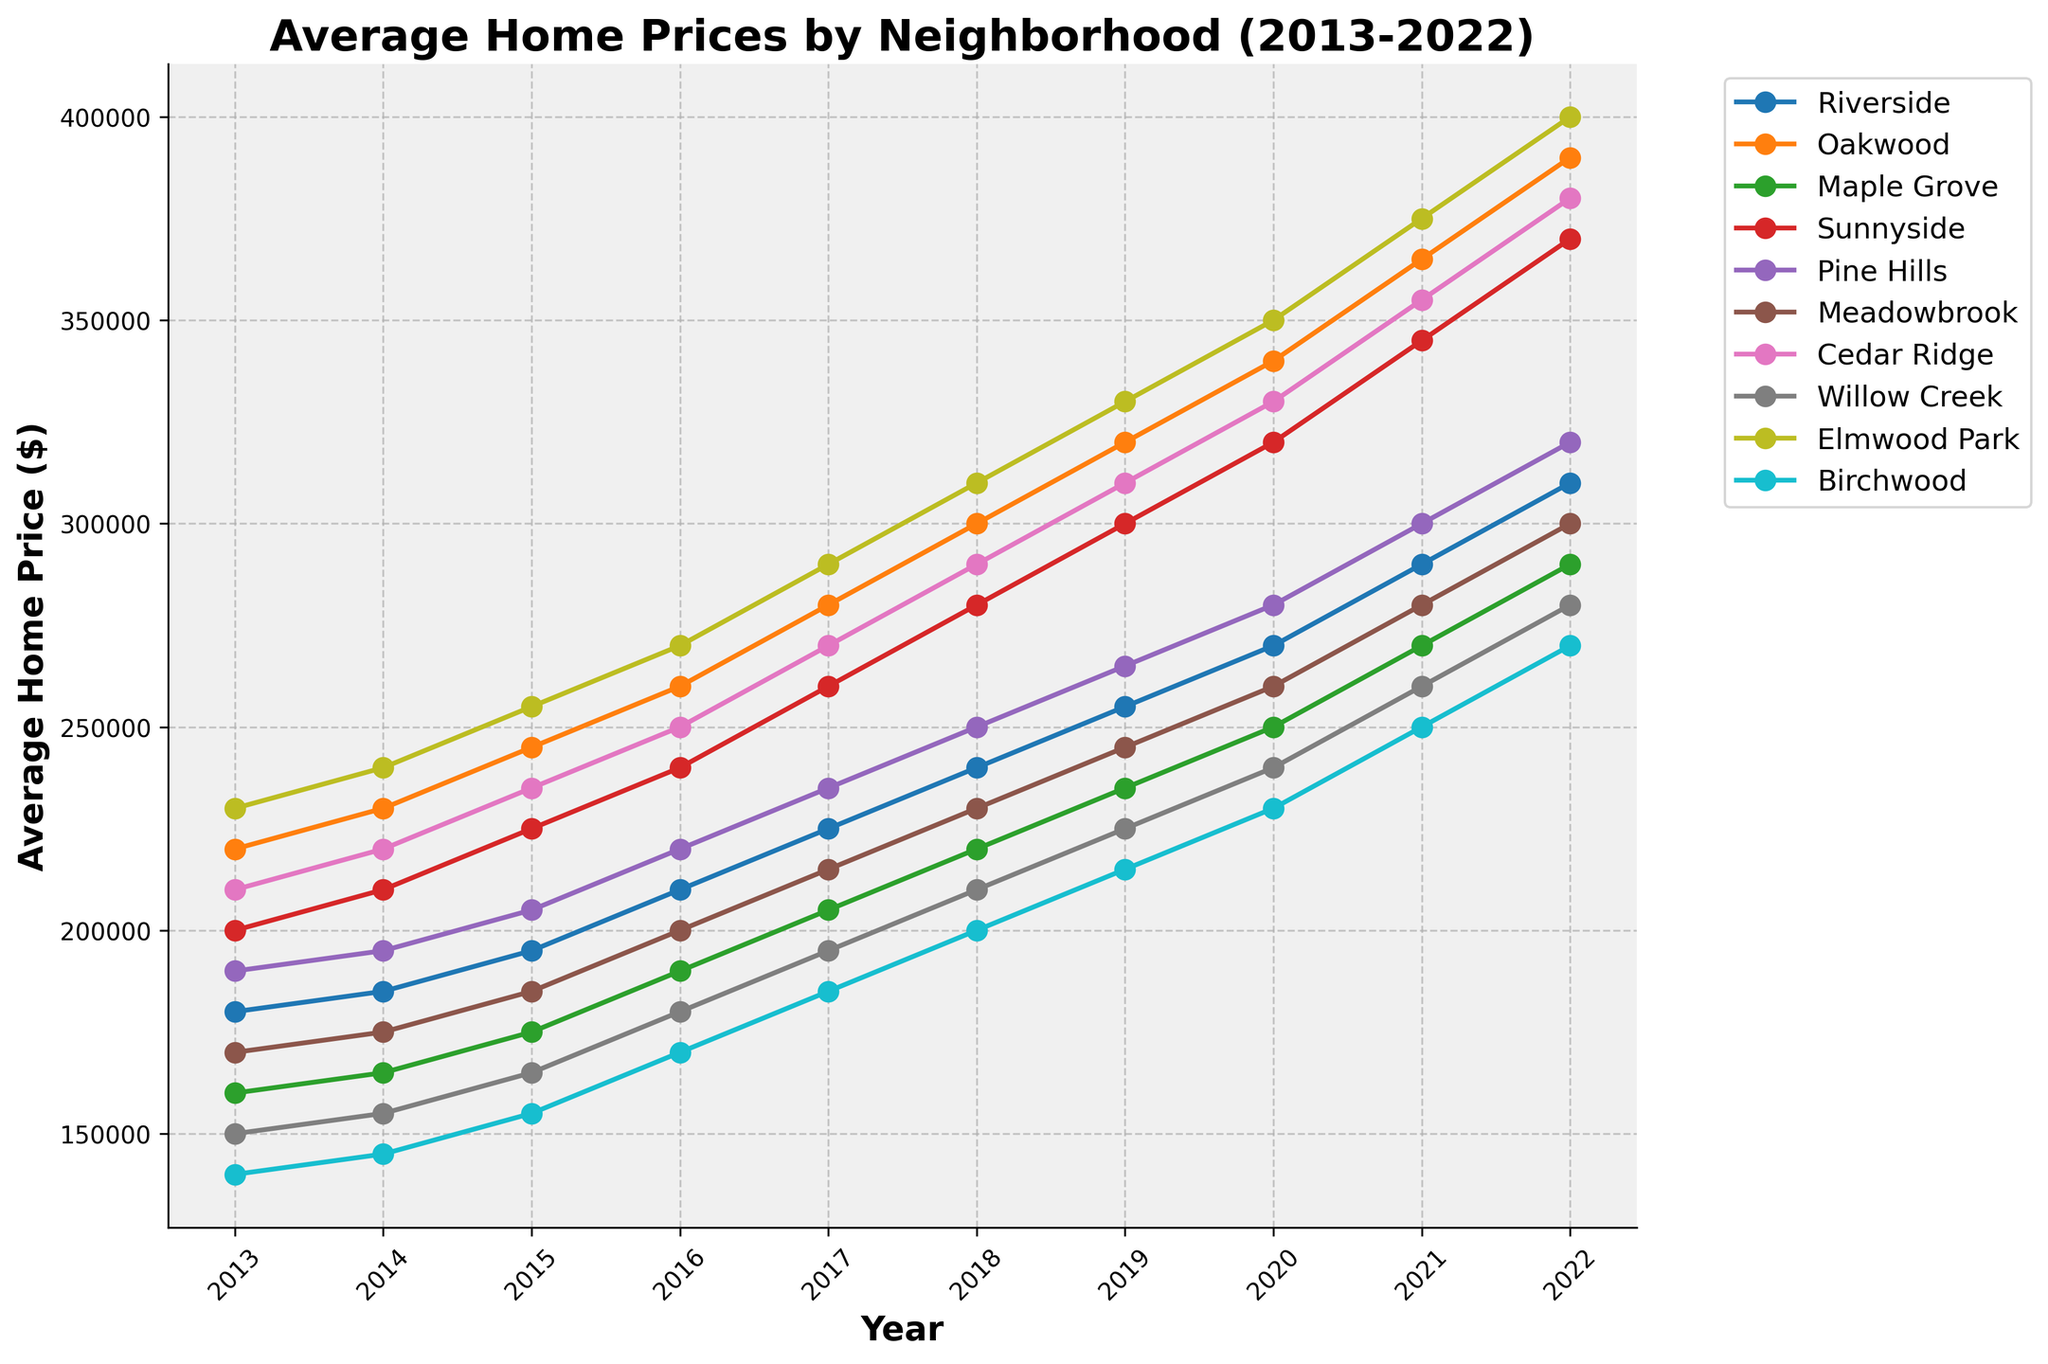What is the average home price in Riverside in 2020? To find the average home price in Riverside in 2020, look at the data point corresponding to Riverside and the year 2020 on the graph.
Answer: $270,000 Which neighborhood had the highest home price in 2021? From the graph, compare all the home prices in 2021 and identify the highest one. Elmwood Park has the highest price point in 2021.
Answer: Elmwood Park How much did the average home price increase in Maple Grove from 2015 to 2022? In 2015, the average home price in Maple Grove was $175,000, and in 2022 it was $290,000. The increase is calculated by subtracting the 2015 value from the 2022 value: $290,000 - $175,000.
Answer: $115,000 Which neighborhood showed the most significant increase in home prices from 2013 to 2022? Analyze the difference between 2022 and 2013 for each neighborhood. Elmwood Park increased from $230,000 to $400,000. This $170,000 increase is the largest.
Answer: Elmwood Park Did any neighborhood's average home price decrease at any point in the 10-year period? Visually inspect each line on the graph for any downward trend over the years. None of the neighborhoods have a line that slopes downward at any point.
Answer: No Which two neighborhoods had the closest average home price in 2018? On the graph at the 2018 marker, compare the price points of the neighborhoods. Riverside and Pine Hills were both at around $240,000 and $250,000, respectively, which are very close.
Answer: Riverside and Pine Hills By how much did the home prices in Sunnyside increase between 2017 and 2018? The home price in Sunnyside was $260,000 in 2017 and $280,000 in 2018. The increase is the difference: $280,000 - $260,000.
Answer: $20,000 Which neighborhood had the lowest home price in 2019? Observe the graph and identify the lowest point for the year 2019. Birchwood had the lowest price at $215,000.
Answer: Birchwood 